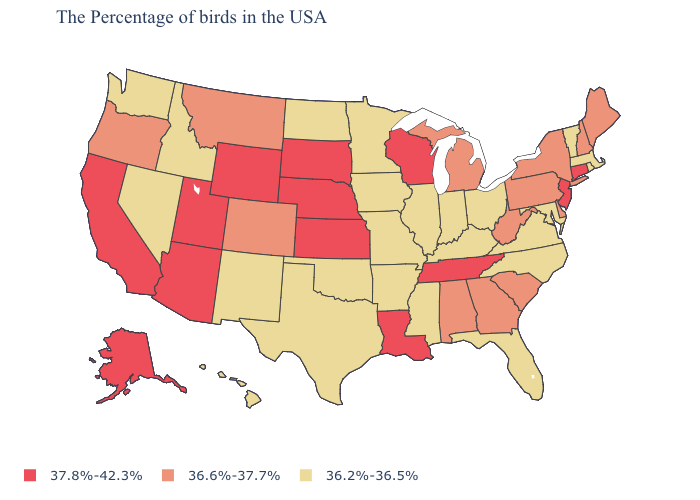Does Mississippi have a lower value than Minnesota?
Be succinct. No. What is the value of Hawaii?
Write a very short answer. 36.2%-36.5%. Among the states that border Idaho , which have the lowest value?
Concise answer only. Nevada, Washington. How many symbols are there in the legend?
Quick response, please. 3. Among the states that border Arkansas , which have the highest value?
Write a very short answer. Tennessee, Louisiana. What is the highest value in the Northeast ?
Answer briefly. 37.8%-42.3%. What is the highest value in the USA?
Keep it brief. 37.8%-42.3%. Does Montana have the lowest value in the West?
Give a very brief answer. No. Which states have the highest value in the USA?
Give a very brief answer. Connecticut, New Jersey, Tennessee, Wisconsin, Louisiana, Kansas, Nebraska, South Dakota, Wyoming, Utah, Arizona, California, Alaska. Among the states that border Missouri , does Iowa have the highest value?
Keep it brief. No. What is the value of Michigan?
Answer briefly. 36.6%-37.7%. How many symbols are there in the legend?
Quick response, please. 3. Which states have the highest value in the USA?
Give a very brief answer. Connecticut, New Jersey, Tennessee, Wisconsin, Louisiana, Kansas, Nebraska, South Dakota, Wyoming, Utah, Arizona, California, Alaska. Does Tennessee have the same value as Montana?
Short answer required. No. Name the states that have a value in the range 36.6%-37.7%?
Be succinct. Maine, New Hampshire, New York, Delaware, Pennsylvania, South Carolina, West Virginia, Georgia, Michigan, Alabama, Colorado, Montana, Oregon. 